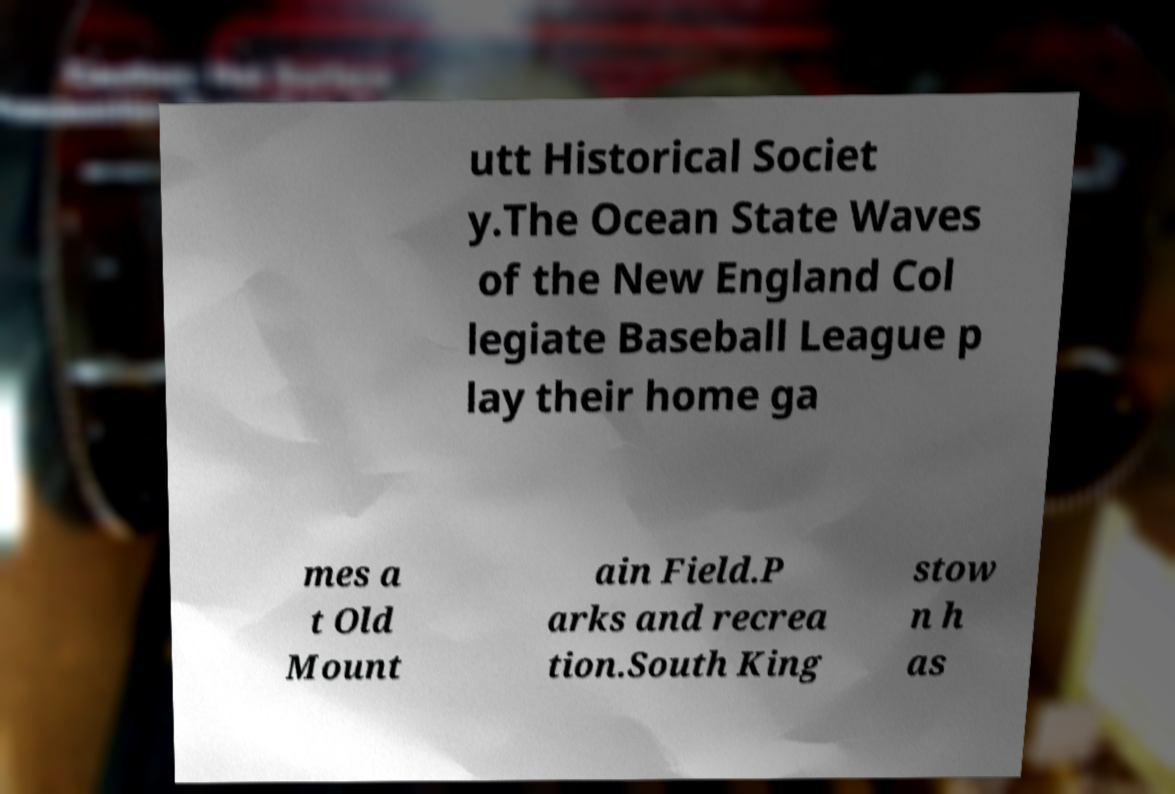I need the written content from this picture converted into text. Can you do that? utt Historical Societ y.The Ocean State Waves of the New England Col legiate Baseball League p lay their home ga mes a t Old Mount ain Field.P arks and recrea tion.South King stow n h as 